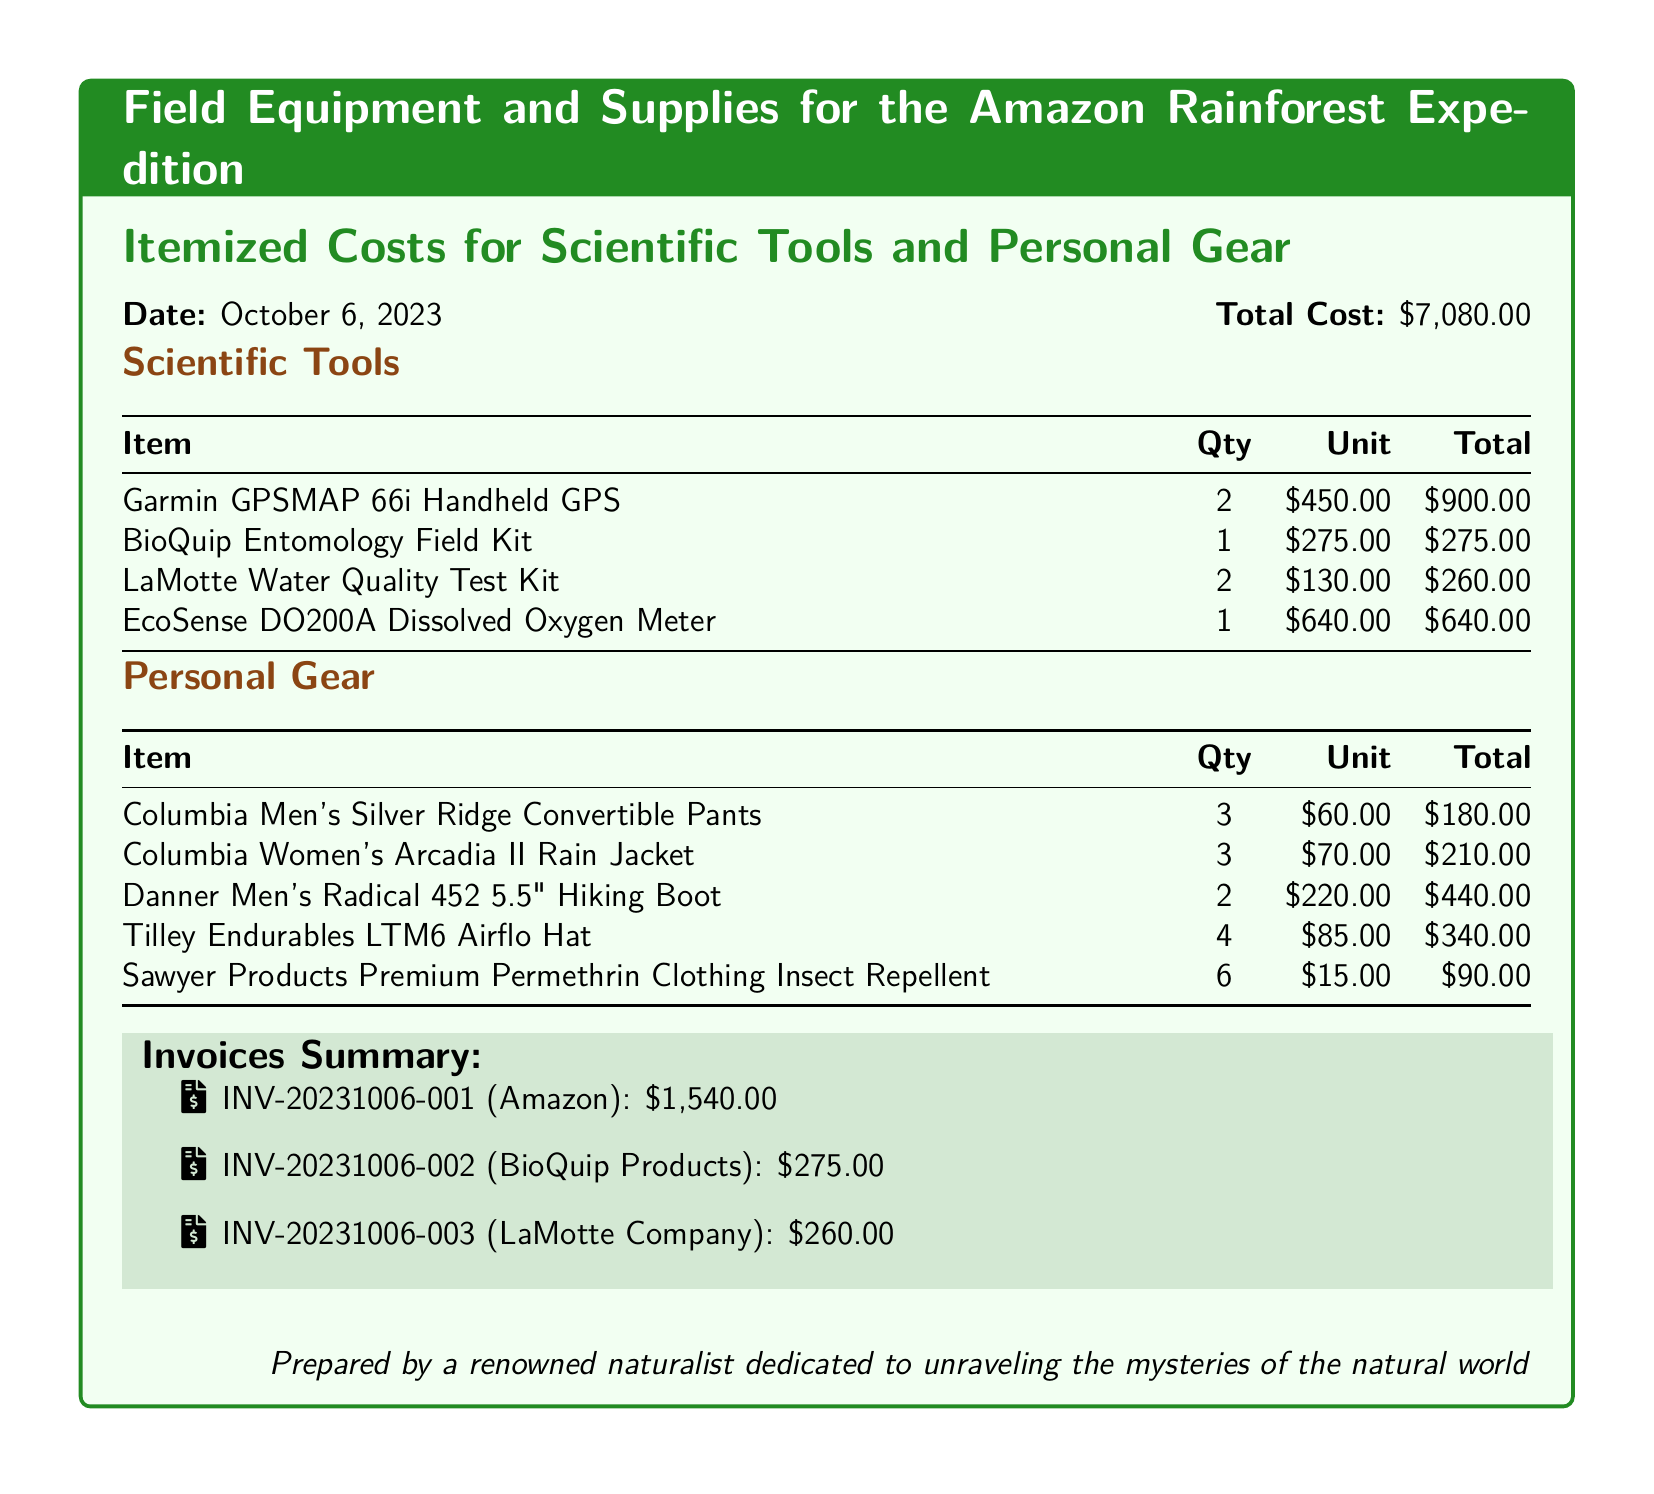What is the total cost of the expedition supplies? The total cost is explicitly stated in the document as $7,080.00.
Answer: $7,080.00 How many Garmin GPSMAP 66i Handheld GPS devices were purchased? The quantity of Garmin GPSMAP 66i devices is listed in the itemized costs.
Answer: 2 What is the unit price of the BioQuip Entomology Field Kit? The unit price for the BioQuip Entomology Field Kit can be retrieved from the table of scientific tools.
Answer: $275.00 How many Tilley Endurables LTM6 Airflo Hats were bought? The number of Tilley Endurables hats purchased is noted under personal gear.
Answer: 4 What is the invoice number for the Amazon purchase? The invoice number for the Amazon purchase is listed in the invoices summary.
Answer: INV-20231006-001 Calculate the total cost of personal gear. The total cost of personal gear can be calculated by adding the individual costs listed in the personal gear table, which equals $1,440.00.
Answer: $1,440.00 What item from the scientific tools section has the highest cost? The item with the highest cost in the scientific tools section is the EcoSense DO200A Dissolved Oxygen Meter.
Answer: EcoSense DO200A Dissolved Oxygen Meter What is the total quantity of LaMotte Water Quality Test Kits purchased? The quantity of LaMotte Water Quality Test Kits is specified in the document itemized costs.
Answer: 2 Which company supplied the BioQuip Entomology Field Kit? The company that supplied the BioQuip Entomology Field Kit can be found next to its item in the scientific tools section.
Answer: BioQuip Products 